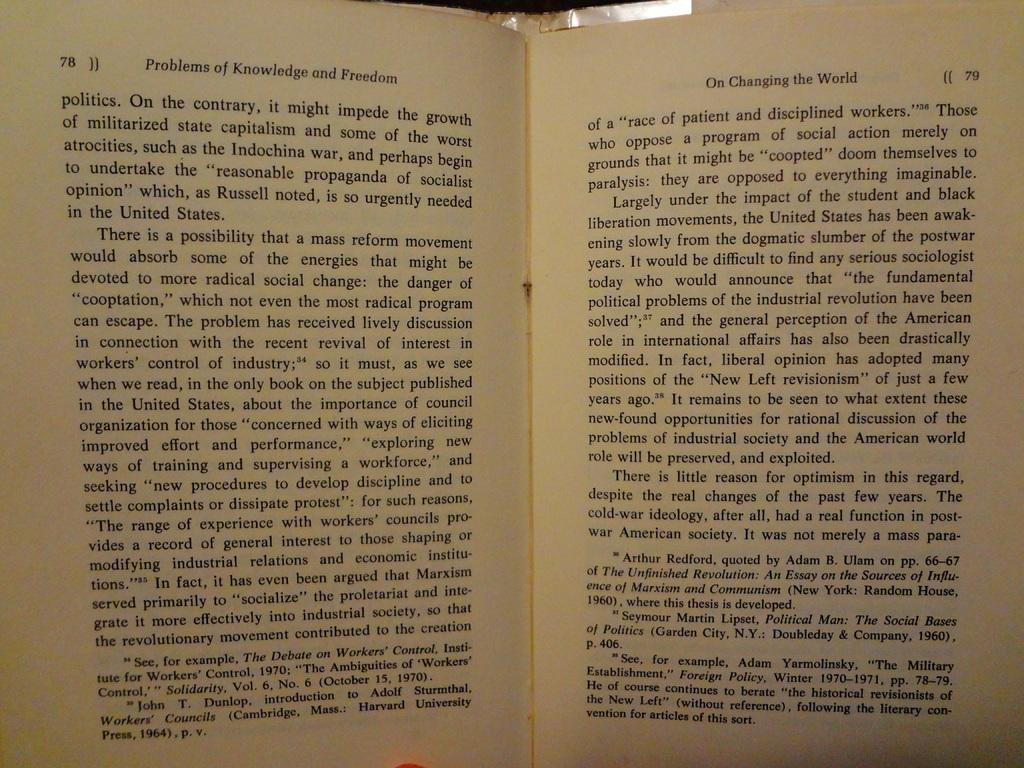What is the title of this book?
Ensure brevity in your answer.  Problems of knowledge and freedom. What number is the left page?
Provide a succinct answer. 78. 